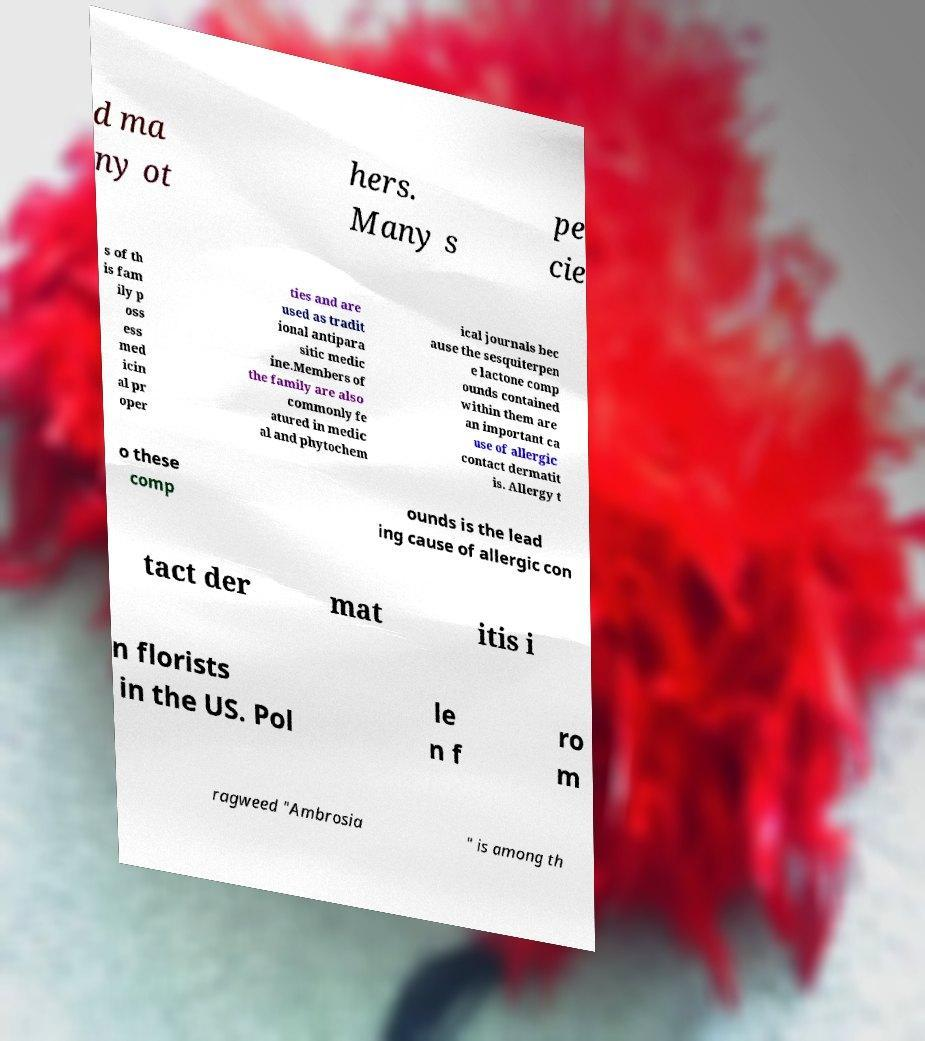Can you read and provide the text displayed in the image?This photo seems to have some interesting text. Can you extract and type it out for me? d ma ny ot hers. Many s pe cie s of th is fam ily p oss ess med icin al pr oper ties and are used as tradit ional antipara sitic medic ine.Members of the family are also commonly fe atured in medic al and phytochem ical journals bec ause the sesquiterpen e lactone comp ounds contained within them are an important ca use of allergic contact dermatit is. Allergy t o these comp ounds is the lead ing cause of allergic con tact der mat itis i n florists in the US. Pol le n f ro m ragweed "Ambrosia " is among th 